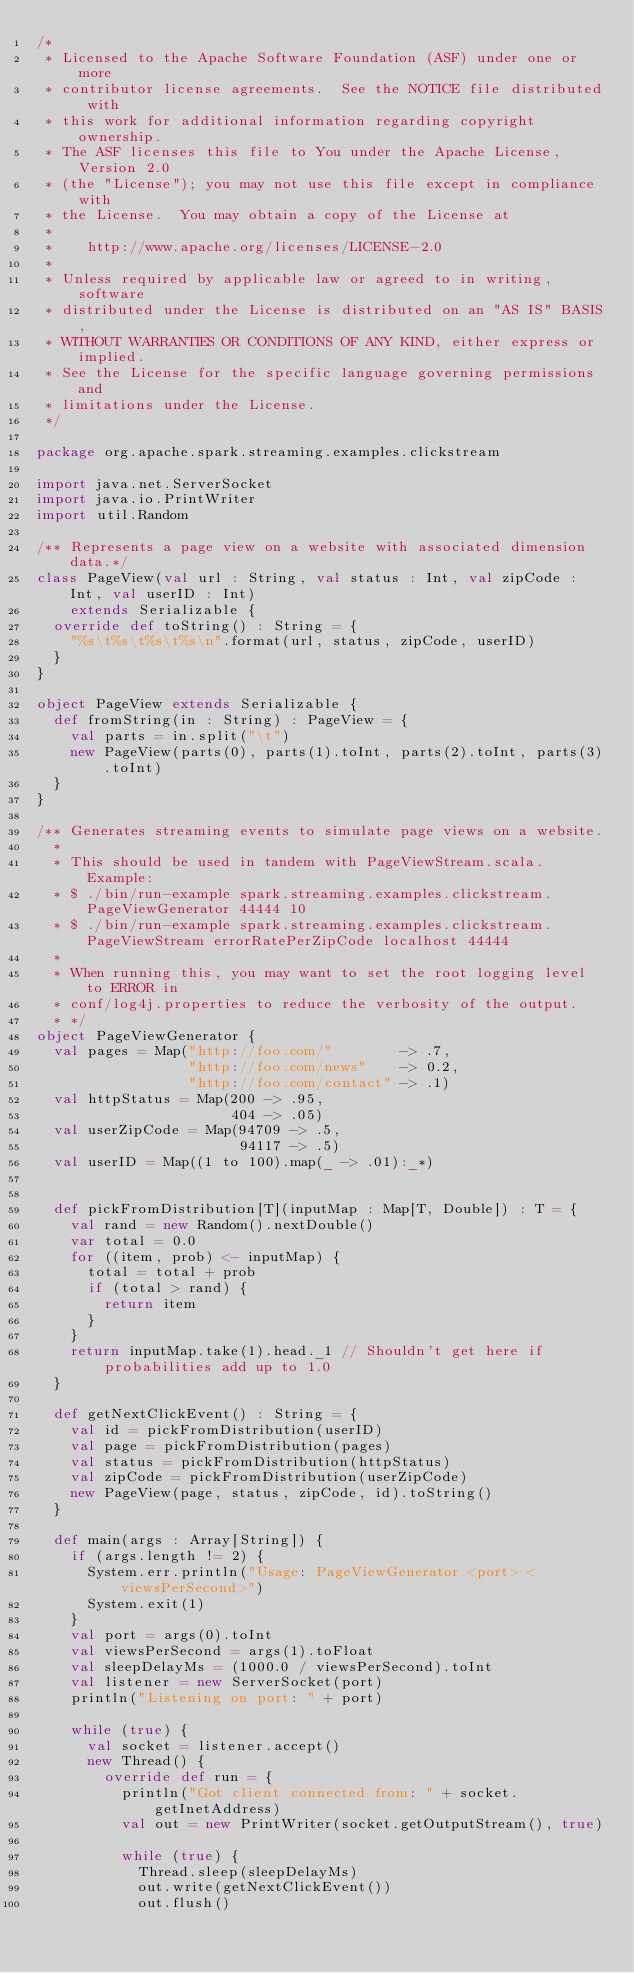<code> <loc_0><loc_0><loc_500><loc_500><_Scala_>/*
 * Licensed to the Apache Software Foundation (ASF) under one or more
 * contributor license agreements.  See the NOTICE file distributed with
 * this work for additional information regarding copyright ownership.
 * The ASF licenses this file to You under the Apache License, Version 2.0
 * (the "License"); you may not use this file except in compliance with
 * the License.  You may obtain a copy of the License at
 *
 *    http://www.apache.org/licenses/LICENSE-2.0
 *
 * Unless required by applicable law or agreed to in writing, software
 * distributed under the License is distributed on an "AS IS" BASIS,
 * WITHOUT WARRANTIES OR CONDITIONS OF ANY KIND, either express or implied.
 * See the License for the specific language governing permissions and
 * limitations under the License.
 */

package org.apache.spark.streaming.examples.clickstream

import java.net.ServerSocket
import java.io.PrintWriter
import util.Random

/** Represents a page view on a website with associated dimension data.*/
class PageView(val url : String, val status : Int, val zipCode : Int, val userID : Int)
    extends Serializable {
  override def toString() : String = {
    "%s\t%s\t%s\t%s\n".format(url, status, zipCode, userID)
  }
}

object PageView extends Serializable {
  def fromString(in : String) : PageView = {
    val parts = in.split("\t")
    new PageView(parts(0), parts(1).toInt, parts(2).toInt, parts(3).toInt)
  }
}

/** Generates streaming events to simulate page views on a website.
  *
  * This should be used in tandem with PageViewStream.scala. Example:
  * $ ./bin/run-example spark.streaming.examples.clickstream.PageViewGenerator 44444 10
  * $ ./bin/run-example spark.streaming.examples.clickstream.PageViewStream errorRatePerZipCode localhost 44444
  *
  * When running this, you may want to set the root logging level to ERROR in
  * conf/log4j.properties to reduce the verbosity of the output.
  * */
object PageViewGenerator {
  val pages = Map("http://foo.com/"        -> .7,
                  "http://foo.com/news"    -> 0.2,
                  "http://foo.com/contact" -> .1)
  val httpStatus = Map(200 -> .95,
                       404 -> .05)
  val userZipCode = Map(94709 -> .5,
                        94117 -> .5)
  val userID = Map((1 to 100).map(_ -> .01):_*)


  def pickFromDistribution[T](inputMap : Map[T, Double]) : T = {
    val rand = new Random().nextDouble()
    var total = 0.0
    for ((item, prob) <- inputMap) {
      total = total + prob
      if (total > rand) {
        return item
      }
    }
    return inputMap.take(1).head._1 // Shouldn't get here if probabilities add up to 1.0
  }

  def getNextClickEvent() : String = {
    val id = pickFromDistribution(userID)
    val page = pickFromDistribution(pages)
    val status = pickFromDistribution(httpStatus)
    val zipCode = pickFromDistribution(userZipCode)
    new PageView(page, status, zipCode, id).toString()
  }

  def main(args : Array[String]) {
    if (args.length != 2) {
      System.err.println("Usage: PageViewGenerator <port> <viewsPerSecond>")
      System.exit(1)
    }
    val port = args(0).toInt
    val viewsPerSecond = args(1).toFloat
    val sleepDelayMs = (1000.0 / viewsPerSecond).toInt
    val listener = new ServerSocket(port)
    println("Listening on port: " + port)

    while (true) {
      val socket = listener.accept()
      new Thread() {
        override def run = {
          println("Got client connected from: " + socket.getInetAddress)
          val out = new PrintWriter(socket.getOutputStream(), true)

          while (true) {
            Thread.sleep(sleepDelayMs)
            out.write(getNextClickEvent())
            out.flush()</code> 